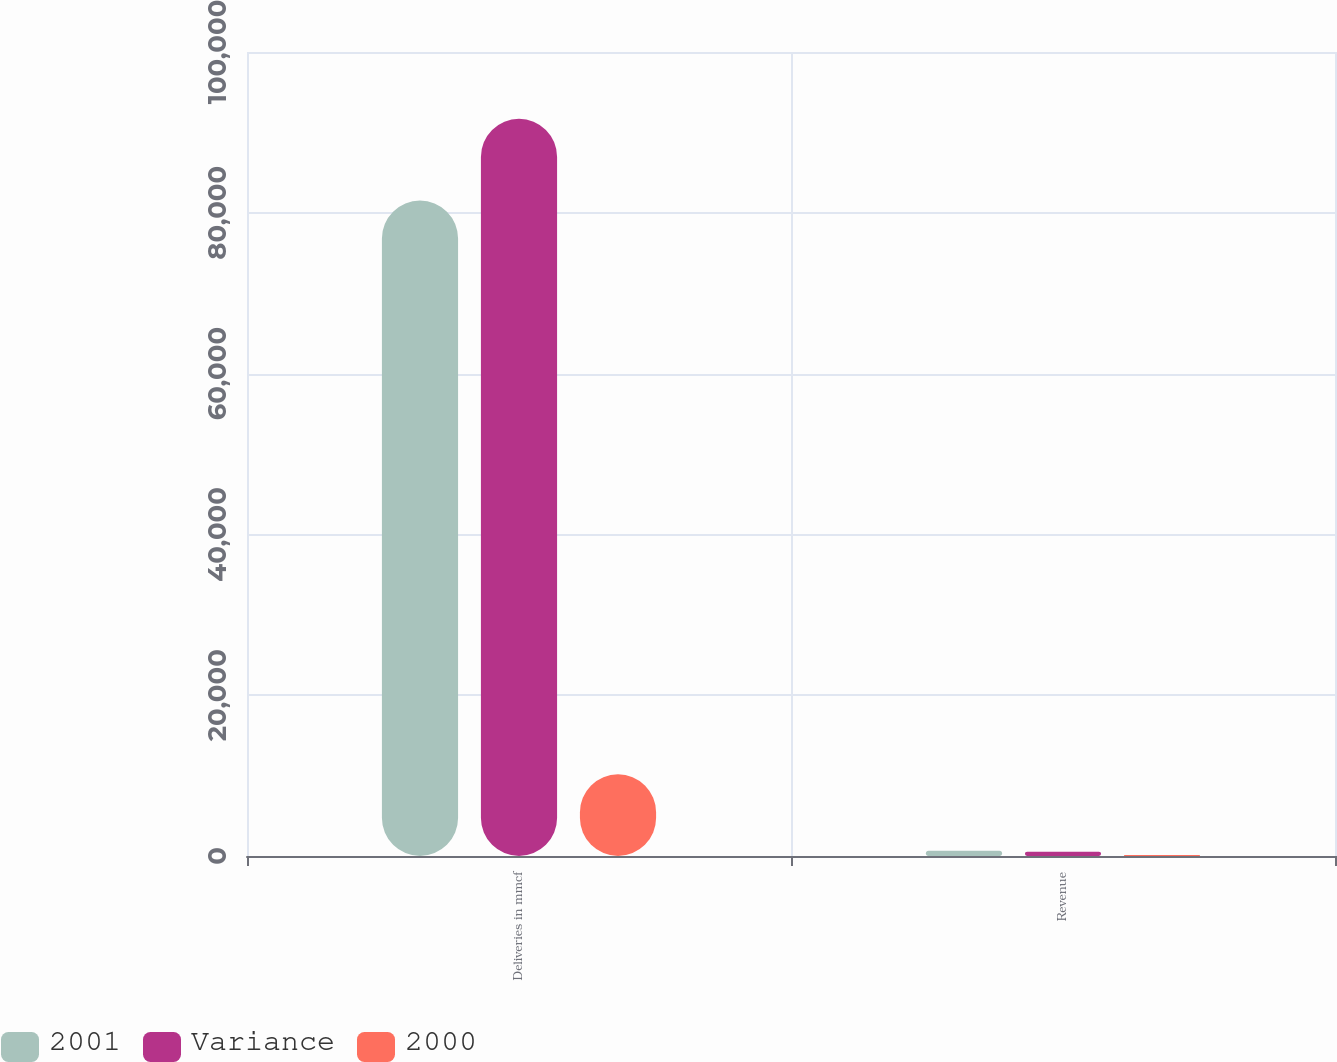Convert chart. <chart><loc_0><loc_0><loc_500><loc_500><stacked_bar_chart><ecel><fcel>Deliveries in mmcf<fcel>Revenue<nl><fcel>2001<fcel>81528<fcel>654<nl><fcel>Variance<fcel>91686<fcel>532<nl><fcel>2000<fcel>10158<fcel>122<nl></chart> 